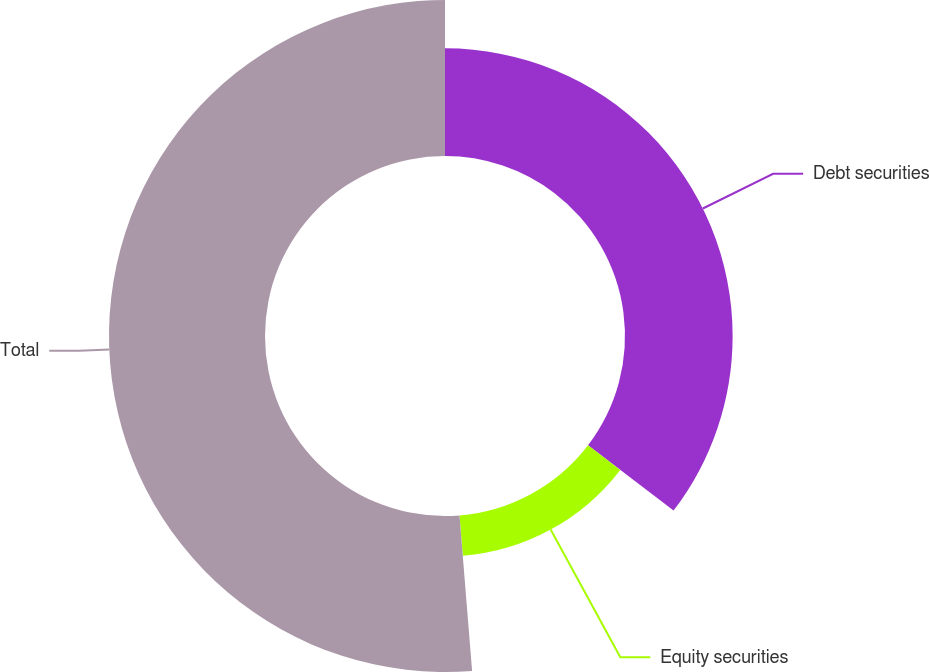<chart> <loc_0><loc_0><loc_500><loc_500><pie_chart><fcel>Debt securities<fcel>Equity securities<fcel>Total<nl><fcel>35.38%<fcel>13.33%<fcel>51.28%<nl></chart> 